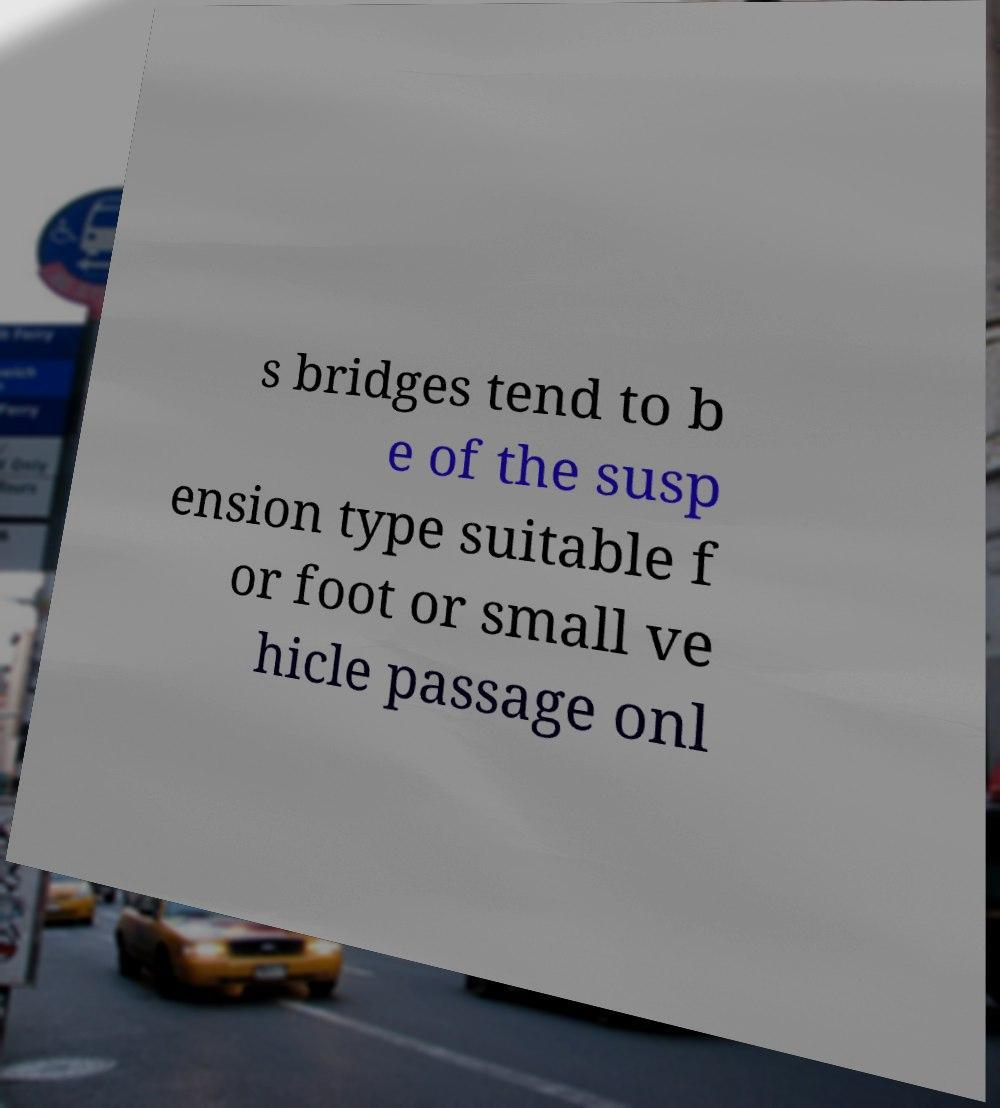There's text embedded in this image that I need extracted. Can you transcribe it verbatim? s bridges tend to b e of the susp ension type suitable f or foot or small ve hicle passage onl 